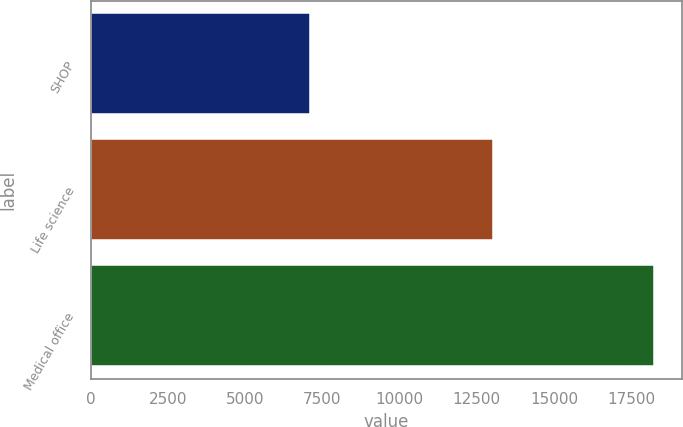Convert chart to OTSL. <chart><loc_0><loc_0><loc_500><loc_500><bar_chart><fcel>SHOP<fcel>Life science<fcel>Medical office<nl><fcel>7115<fcel>13019<fcel>18229<nl></chart> 